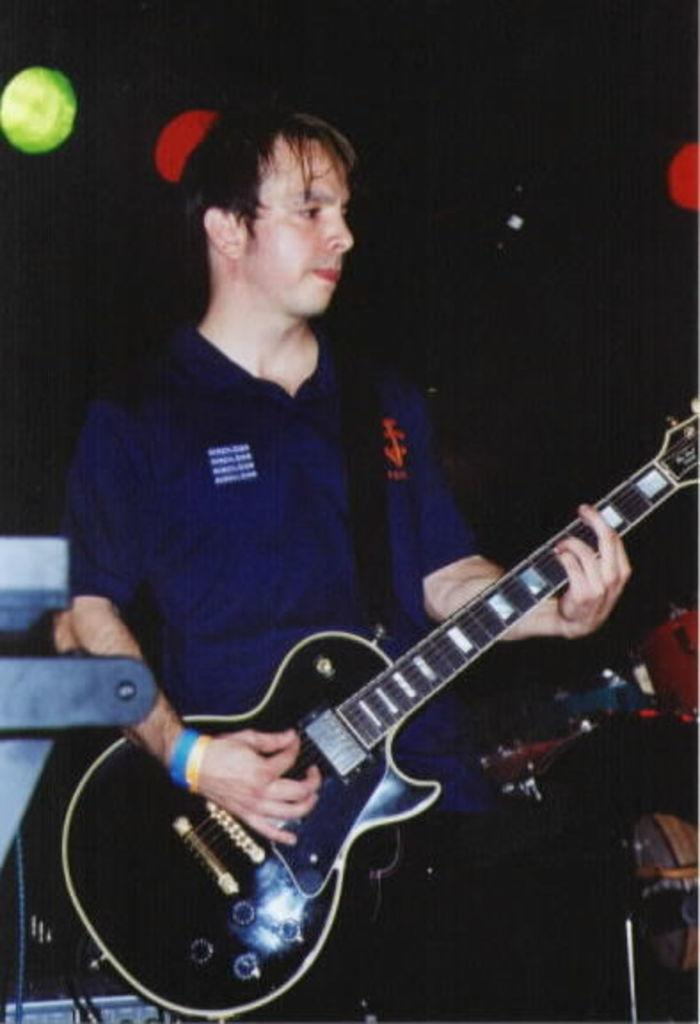What is the person in the image doing? The person is standing in the image and holding a music instrument. What can you tell about the music instrument? The music instrument is black in color. What is the color of the sky in the background of the image? The sky in the background of the image is black. Can you see the person measuring the road in the image? There is no road or measuring activity present in the image. 